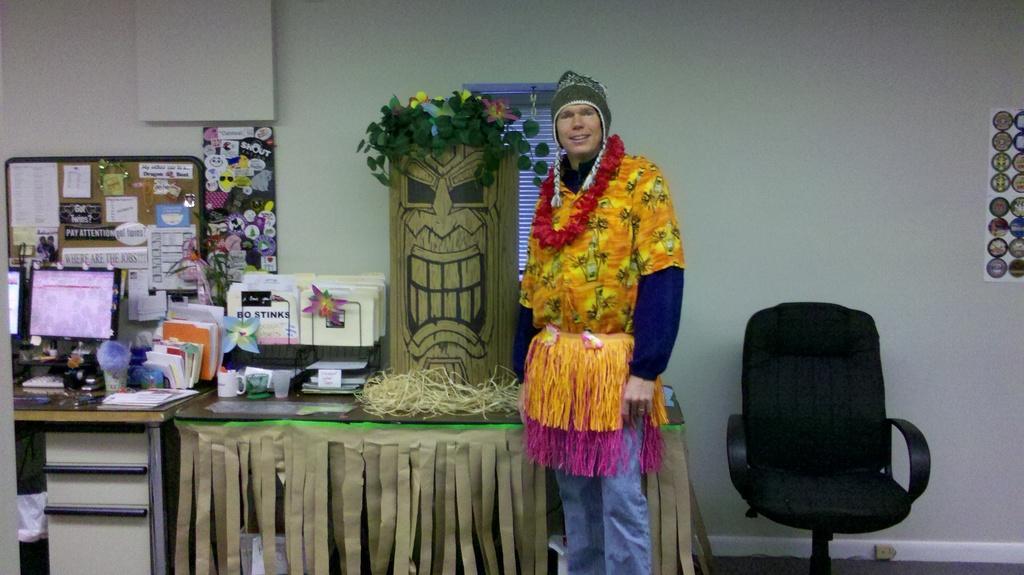Could you give a brief overview of what you see in this image? Here we can see a man wearing a costume and a Garland and on the right side we can see a chair present and at the left side we can see tables present with plants, with books and with system 